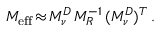<formula> <loc_0><loc_0><loc_500><loc_500>M _ { e f f } \, \approx \, M _ { \nu } ^ { D } \, M _ { R } ^ { - 1 } \, ( M _ { \nu } ^ { D } ) ^ { T } \, .</formula> 